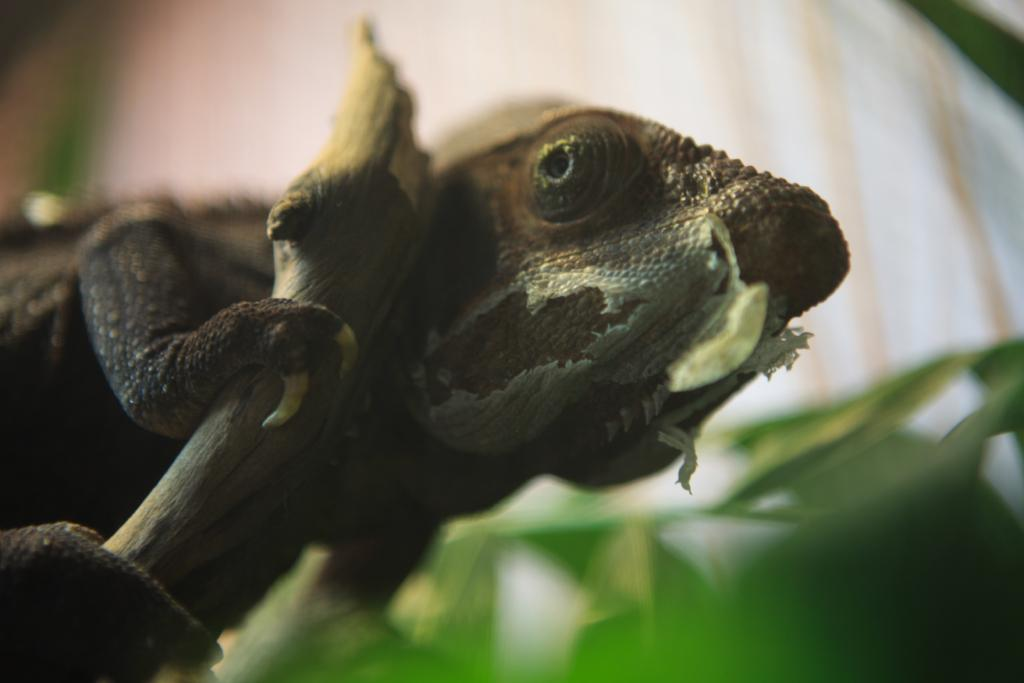What type of animal is in the image? There is a chameleon in the image. What is the chameleon sitting on? The chameleon is sitting on a branch in the image. Can you describe the background of the image? The background appears blurry in the image. What type of work is the chameleon doing in the image? The chameleon is not performing any work in the image; it is simply sitting on a branch. 